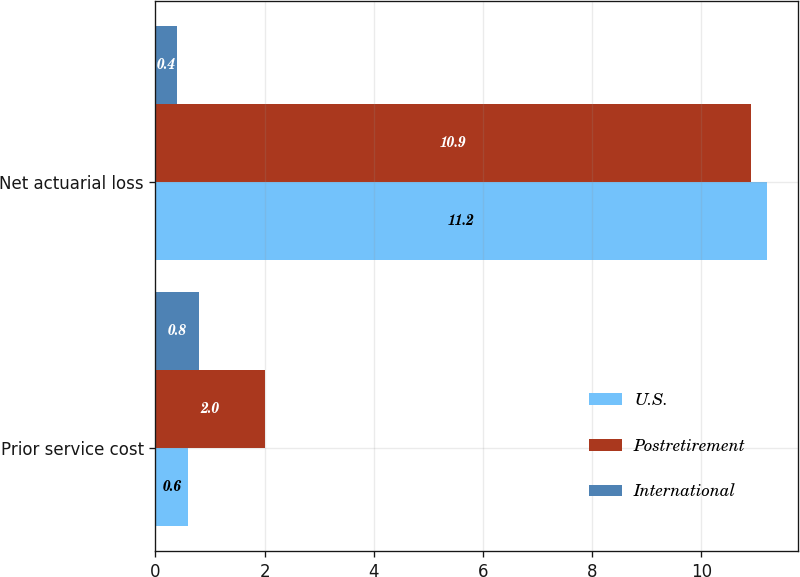<chart> <loc_0><loc_0><loc_500><loc_500><stacked_bar_chart><ecel><fcel>Prior service cost<fcel>Net actuarial loss<nl><fcel>U.S.<fcel>0.6<fcel>11.2<nl><fcel>Postretirement<fcel>2<fcel>10.9<nl><fcel>International<fcel>0.8<fcel>0.4<nl></chart> 